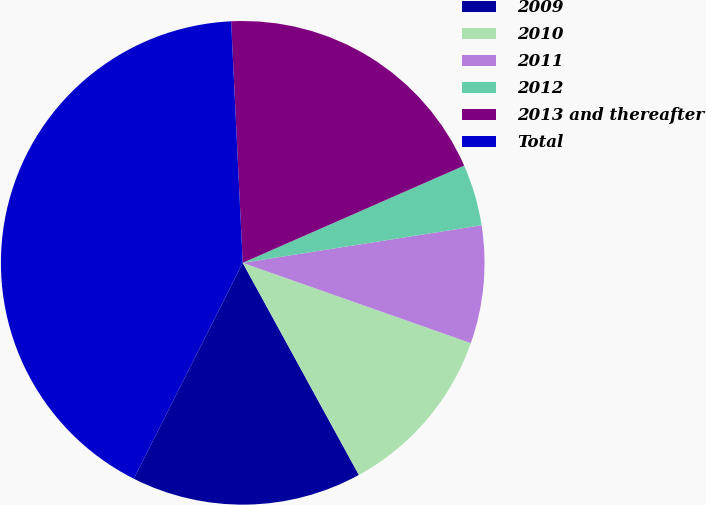Convert chart. <chart><loc_0><loc_0><loc_500><loc_500><pie_chart><fcel>2009<fcel>2010<fcel>2011<fcel>2012<fcel>2013 and thereafter<fcel>Total<nl><fcel>15.41%<fcel>11.64%<fcel>7.87%<fcel>4.1%<fcel>19.18%<fcel>41.8%<nl></chart> 